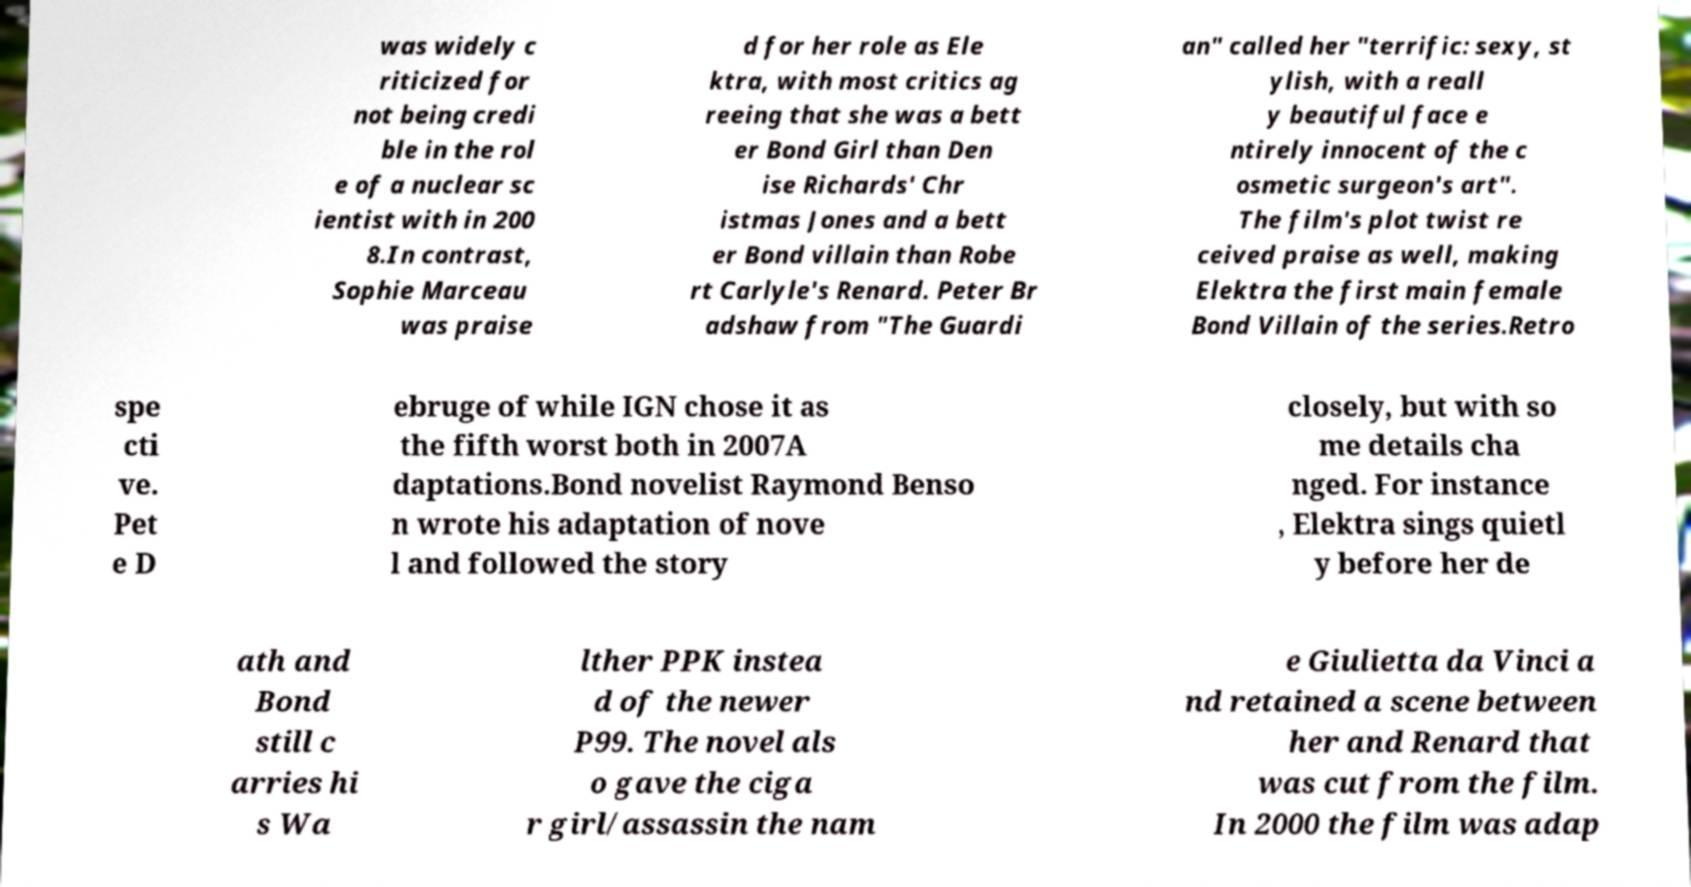Please read and relay the text visible in this image. What does it say? was widely c riticized for not being credi ble in the rol e of a nuclear sc ientist with in 200 8.In contrast, Sophie Marceau was praise d for her role as Ele ktra, with most critics ag reeing that she was a bett er Bond Girl than Den ise Richards' Chr istmas Jones and a bett er Bond villain than Robe rt Carlyle's Renard. Peter Br adshaw from "The Guardi an" called her "terrific: sexy, st ylish, with a reall y beautiful face e ntirely innocent of the c osmetic surgeon's art". The film's plot twist re ceived praise as well, making Elektra the first main female Bond Villain of the series.Retro spe cti ve. Pet e D ebruge of while IGN chose it as the fifth worst both in 2007A daptations.Bond novelist Raymond Benso n wrote his adaptation of nove l and followed the story closely, but with so me details cha nged. For instance , Elektra sings quietl y before her de ath and Bond still c arries hi s Wa lther PPK instea d of the newer P99. The novel als o gave the ciga r girl/assassin the nam e Giulietta da Vinci a nd retained a scene between her and Renard that was cut from the film. In 2000 the film was adap 